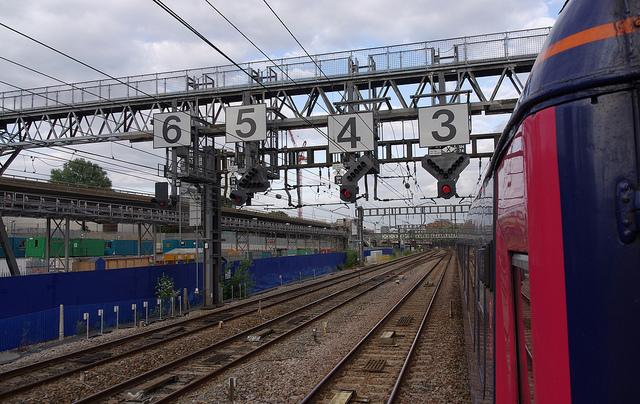What numbers are visible?
Answer briefly. 6 5 4 3. What color is the train?
Keep it brief. Red and blue. Which track is train on?
Concise answer only. 2. How many trees are in the picture?
Answer briefly. 1. 